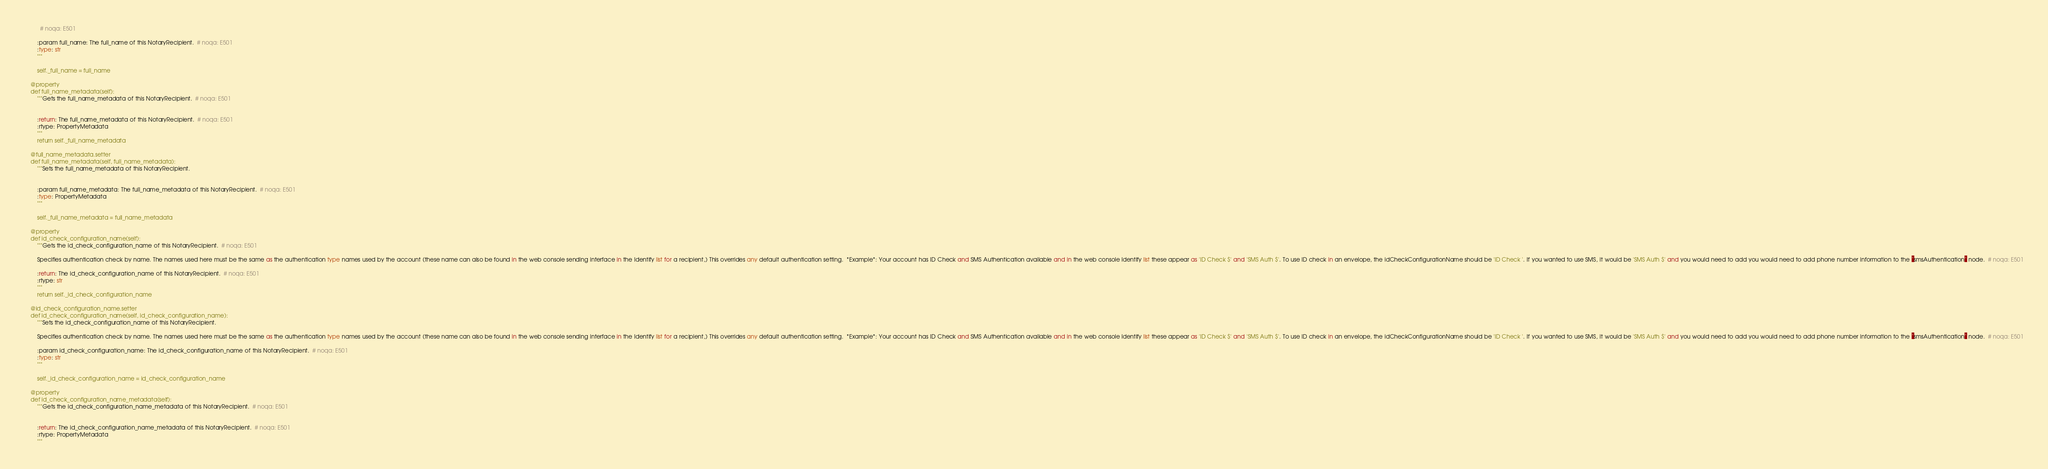<code> <loc_0><loc_0><loc_500><loc_500><_Python_>          # noqa: E501

        :param full_name: The full_name of this NotaryRecipient.  # noqa: E501
        :type: str
        """

        self._full_name = full_name

    @property
    def full_name_metadata(self):
        """Gets the full_name_metadata of this NotaryRecipient.  # noqa: E501


        :return: The full_name_metadata of this NotaryRecipient.  # noqa: E501
        :rtype: PropertyMetadata
        """
        return self._full_name_metadata

    @full_name_metadata.setter
    def full_name_metadata(self, full_name_metadata):
        """Sets the full_name_metadata of this NotaryRecipient.


        :param full_name_metadata: The full_name_metadata of this NotaryRecipient.  # noqa: E501
        :type: PropertyMetadata
        """

        self._full_name_metadata = full_name_metadata

    @property
    def id_check_configuration_name(self):
        """Gets the id_check_configuration_name of this NotaryRecipient.  # noqa: E501

        Specifies authentication check by name. The names used here must be the same as the authentication type names used by the account (these name can also be found in the web console sending interface in the Identify list for a recipient,) This overrides any default authentication setting.  *Example*: Your account has ID Check and SMS Authentication available and in the web console Identify list these appear as 'ID Check $' and 'SMS Auth $'. To use ID check in an envelope, the idCheckConfigurationName should be 'ID Check '. If you wanted to use SMS, it would be 'SMS Auth $' and you would need to add you would need to add phone number information to the `smsAuthentication` node.  # noqa: E501

        :return: The id_check_configuration_name of this NotaryRecipient.  # noqa: E501
        :rtype: str
        """
        return self._id_check_configuration_name

    @id_check_configuration_name.setter
    def id_check_configuration_name(self, id_check_configuration_name):
        """Sets the id_check_configuration_name of this NotaryRecipient.

        Specifies authentication check by name. The names used here must be the same as the authentication type names used by the account (these name can also be found in the web console sending interface in the Identify list for a recipient,) This overrides any default authentication setting.  *Example*: Your account has ID Check and SMS Authentication available and in the web console Identify list these appear as 'ID Check $' and 'SMS Auth $'. To use ID check in an envelope, the idCheckConfigurationName should be 'ID Check '. If you wanted to use SMS, it would be 'SMS Auth $' and you would need to add you would need to add phone number information to the `smsAuthentication` node.  # noqa: E501

        :param id_check_configuration_name: The id_check_configuration_name of this NotaryRecipient.  # noqa: E501
        :type: str
        """

        self._id_check_configuration_name = id_check_configuration_name

    @property
    def id_check_configuration_name_metadata(self):
        """Gets the id_check_configuration_name_metadata of this NotaryRecipient.  # noqa: E501


        :return: The id_check_configuration_name_metadata of this NotaryRecipient.  # noqa: E501
        :rtype: PropertyMetadata
        """</code> 